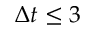Convert formula to latex. <formula><loc_0><loc_0><loc_500><loc_500>\Delta t \leq 3</formula> 